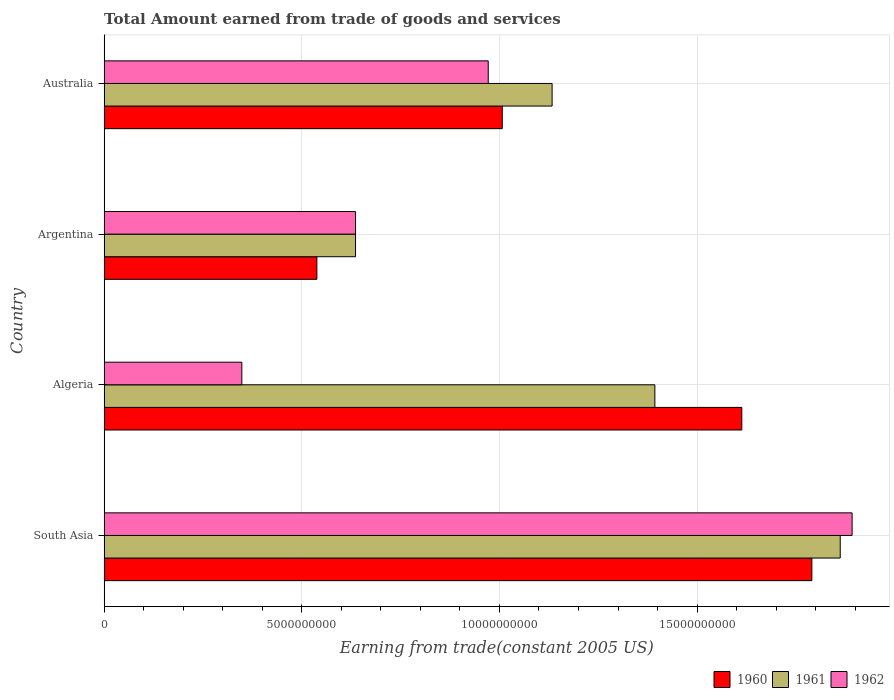Are the number of bars per tick equal to the number of legend labels?
Offer a terse response. Yes. Are the number of bars on each tick of the Y-axis equal?
Give a very brief answer. Yes. How many bars are there on the 3rd tick from the top?
Your answer should be very brief. 3. What is the label of the 3rd group of bars from the top?
Ensure brevity in your answer.  Algeria. In how many cases, is the number of bars for a given country not equal to the number of legend labels?
Ensure brevity in your answer.  0. What is the total amount earned by trading goods and services in 1960 in South Asia?
Offer a very short reply. 1.79e+1. Across all countries, what is the maximum total amount earned by trading goods and services in 1962?
Offer a very short reply. 1.89e+1. Across all countries, what is the minimum total amount earned by trading goods and services in 1962?
Keep it short and to the point. 3.48e+09. In which country was the total amount earned by trading goods and services in 1960 maximum?
Your answer should be compact. South Asia. What is the total total amount earned by trading goods and services in 1960 in the graph?
Offer a very short reply. 4.95e+1. What is the difference between the total amount earned by trading goods and services in 1962 in Algeria and that in South Asia?
Offer a terse response. -1.54e+1. What is the difference between the total amount earned by trading goods and services in 1960 in Algeria and the total amount earned by trading goods and services in 1961 in Australia?
Ensure brevity in your answer.  4.80e+09. What is the average total amount earned by trading goods and services in 1962 per country?
Your answer should be very brief. 9.62e+09. What is the difference between the total amount earned by trading goods and services in 1960 and total amount earned by trading goods and services in 1961 in Argentina?
Offer a terse response. -9.78e+08. What is the ratio of the total amount earned by trading goods and services in 1962 in Algeria to that in Argentina?
Offer a terse response. 0.55. Is the total amount earned by trading goods and services in 1962 in Australia less than that in South Asia?
Your response must be concise. Yes. What is the difference between the highest and the second highest total amount earned by trading goods and services in 1961?
Provide a short and direct response. 4.69e+09. What is the difference between the highest and the lowest total amount earned by trading goods and services in 1960?
Offer a terse response. 1.25e+1. What does the 2nd bar from the top in Algeria represents?
Give a very brief answer. 1961. Is it the case that in every country, the sum of the total amount earned by trading goods and services in 1961 and total amount earned by trading goods and services in 1960 is greater than the total amount earned by trading goods and services in 1962?
Keep it short and to the point. Yes. What is the difference between two consecutive major ticks on the X-axis?
Keep it short and to the point. 5.00e+09. Are the values on the major ticks of X-axis written in scientific E-notation?
Ensure brevity in your answer.  No. Does the graph contain grids?
Offer a very short reply. Yes. How are the legend labels stacked?
Offer a terse response. Horizontal. What is the title of the graph?
Ensure brevity in your answer.  Total Amount earned from trade of goods and services. What is the label or title of the X-axis?
Give a very brief answer. Earning from trade(constant 2005 US). What is the Earning from trade(constant 2005 US) of 1960 in South Asia?
Provide a short and direct response. 1.79e+1. What is the Earning from trade(constant 2005 US) in 1961 in South Asia?
Your answer should be compact. 1.86e+1. What is the Earning from trade(constant 2005 US) in 1962 in South Asia?
Keep it short and to the point. 1.89e+1. What is the Earning from trade(constant 2005 US) in 1960 in Algeria?
Your response must be concise. 1.61e+1. What is the Earning from trade(constant 2005 US) in 1961 in Algeria?
Offer a very short reply. 1.39e+1. What is the Earning from trade(constant 2005 US) in 1962 in Algeria?
Your response must be concise. 3.48e+09. What is the Earning from trade(constant 2005 US) in 1960 in Argentina?
Your response must be concise. 5.38e+09. What is the Earning from trade(constant 2005 US) of 1961 in Argentina?
Make the answer very short. 6.36e+09. What is the Earning from trade(constant 2005 US) in 1962 in Argentina?
Offer a very short reply. 6.36e+09. What is the Earning from trade(constant 2005 US) in 1960 in Australia?
Your response must be concise. 1.01e+1. What is the Earning from trade(constant 2005 US) of 1961 in Australia?
Provide a succinct answer. 1.13e+1. What is the Earning from trade(constant 2005 US) in 1962 in Australia?
Offer a terse response. 9.72e+09. Across all countries, what is the maximum Earning from trade(constant 2005 US) in 1960?
Your response must be concise. 1.79e+1. Across all countries, what is the maximum Earning from trade(constant 2005 US) of 1961?
Your answer should be compact. 1.86e+1. Across all countries, what is the maximum Earning from trade(constant 2005 US) of 1962?
Give a very brief answer. 1.89e+1. Across all countries, what is the minimum Earning from trade(constant 2005 US) in 1960?
Make the answer very short. 5.38e+09. Across all countries, what is the minimum Earning from trade(constant 2005 US) in 1961?
Ensure brevity in your answer.  6.36e+09. Across all countries, what is the minimum Earning from trade(constant 2005 US) of 1962?
Make the answer very short. 3.48e+09. What is the total Earning from trade(constant 2005 US) in 1960 in the graph?
Offer a terse response. 4.95e+1. What is the total Earning from trade(constant 2005 US) of 1961 in the graph?
Your answer should be very brief. 5.02e+1. What is the total Earning from trade(constant 2005 US) in 1962 in the graph?
Your response must be concise. 3.85e+1. What is the difference between the Earning from trade(constant 2005 US) of 1960 in South Asia and that in Algeria?
Your answer should be compact. 1.77e+09. What is the difference between the Earning from trade(constant 2005 US) of 1961 in South Asia and that in Algeria?
Ensure brevity in your answer.  4.69e+09. What is the difference between the Earning from trade(constant 2005 US) of 1962 in South Asia and that in Algeria?
Offer a very short reply. 1.54e+1. What is the difference between the Earning from trade(constant 2005 US) of 1960 in South Asia and that in Argentina?
Provide a succinct answer. 1.25e+1. What is the difference between the Earning from trade(constant 2005 US) of 1961 in South Asia and that in Argentina?
Provide a short and direct response. 1.23e+1. What is the difference between the Earning from trade(constant 2005 US) in 1962 in South Asia and that in Argentina?
Your answer should be compact. 1.26e+1. What is the difference between the Earning from trade(constant 2005 US) in 1960 in South Asia and that in Australia?
Offer a very short reply. 7.83e+09. What is the difference between the Earning from trade(constant 2005 US) in 1961 in South Asia and that in Australia?
Your answer should be very brief. 7.29e+09. What is the difference between the Earning from trade(constant 2005 US) of 1962 in South Asia and that in Australia?
Your answer should be very brief. 9.20e+09. What is the difference between the Earning from trade(constant 2005 US) in 1960 in Algeria and that in Argentina?
Offer a very short reply. 1.08e+1. What is the difference between the Earning from trade(constant 2005 US) in 1961 in Algeria and that in Argentina?
Offer a terse response. 7.57e+09. What is the difference between the Earning from trade(constant 2005 US) of 1962 in Algeria and that in Argentina?
Your answer should be compact. -2.88e+09. What is the difference between the Earning from trade(constant 2005 US) in 1960 in Algeria and that in Australia?
Your response must be concise. 6.06e+09. What is the difference between the Earning from trade(constant 2005 US) in 1961 in Algeria and that in Australia?
Make the answer very short. 2.60e+09. What is the difference between the Earning from trade(constant 2005 US) of 1962 in Algeria and that in Australia?
Your response must be concise. -6.23e+09. What is the difference between the Earning from trade(constant 2005 US) of 1960 in Argentina and that in Australia?
Provide a short and direct response. -4.69e+09. What is the difference between the Earning from trade(constant 2005 US) in 1961 in Argentina and that in Australia?
Provide a succinct answer. -4.97e+09. What is the difference between the Earning from trade(constant 2005 US) in 1962 in Argentina and that in Australia?
Keep it short and to the point. -3.36e+09. What is the difference between the Earning from trade(constant 2005 US) in 1960 in South Asia and the Earning from trade(constant 2005 US) in 1961 in Algeria?
Provide a short and direct response. 3.97e+09. What is the difference between the Earning from trade(constant 2005 US) of 1960 in South Asia and the Earning from trade(constant 2005 US) of 1962 in Algeria?
Your answer should be compact. 1.44e+1. What is the difference between the Earning from trade(constant 2005 US) of 1961 in South Asia and the Earning from trade(constant 2005 US) of 1962 in Algeria?
Offer a very short reply. 1.51e+1. What is the difference between the Earning from trade(constant 2005 US) of 1960 in South Asia and the Earning from trade(constant 2005 US) of 1961 in Argentina?
Provide a short and direct response. 1.15e+1. What is the difference between the Earning from trade(constant 2005 US) in 1960 in South Asia and the Earning from trade(constant 2005 US) in 1962 in Argentina?
Ensure brevity in your answer.  1.15e+1. What is the difference between the Earning from trade(constant 2005 US) in 1961 in South Asia and the Earning from trade(constant 2005 US) in 1962 in Argentina?
Offer a terse response. 1.23e+1. What is the difference between the Earning from trade(constant 2005 US) in 1960 in South Asia and the Earning from trade(constant 2005 US) in 1961 in Australia?
Your answer should be very brief. 6.57e+09. What is the difference between the Earning from trade(constant 2005 US) of 1960 in South Asia and the Earning from trade(constant 2005 US) of 1962 in Australia?
Ensure brevity in your answer.  8.19e+09. What is the difference between the Earning from trade(constant 2005 US) of 1961 in South Asia and the Earning from trade(constant 2005 US) of 1962 in Australia?
Your answer should be very brief. 8.90e+09. What is the difference between the Earning from trade(constant 2005 US) of 1960 in Algeria and the Earning from trade(constant 2005 US) of 1961 in Argentina?
Your answer should be very brief. 9.77e+09. What is the difference between the Earning from trade(constant 2005 US) in 1960 in Algeria and the Earning from trade(constant 2005 US) in 1962 in Argentina?
Offer a very short reply. 9.77e+09. What is the difference between the Earning from trade(constant 2005 US) in 1961 in Algeria and the Earning from trade(constant 2005 US) in 1962 in Argentina?
Offer a terse response. 7.57e+09. What is the difference between the Earning from trade(constant 2005 US) of 1960 in Algeria and the Earning from trade(constant 2005 US) of 1961 in Australia?
Your answer should be very brief. 4.80e+09. What is the difference between the Earning from trade(constant 2005 US) of 1960 in Algeria and the Earning from trade(constant 2005 US) of 1962 in Australia?
Give a very brief answer. 6.42e+09. What is the difference between the Earning from trade(constant 2005 US) in 1961 in Algeria and the Earning from trade(constant 2005 US) in 1962 in Australia?
Your answer should be very brief. 4.22e+09. What is the difference between the Earning from trade(constant 2005 US) in 1960 in Argentina and the Earning from trade(constant 2005 US) in 1961 in Australia?
Provide a succinct answer. -5.95e+09. What is the difference between the Earning from trade(constant 2005 US) of 1960 in Argentina and the Earning from trade(constant 2005 US) of 1962 in Australia?
Keep it short and to the point. -4.34e+09. What is the difference between the Earning from trade(constant 2005 US) of 1961 in Argentina and the Earning from trade(constant 2005 US) of 1962 in Australia?
Make the answer very short. -3.36e+09. What is the average Earning from trade(constant 2005 US) of 1960 per country?
Give a very brief answer. 1.24e+1. What is the average Earning from trade(constant 2005 US) in 1961 per country?
Your answer should be compact. 1.26e+1. What is the average Earning from trade(constant 2005 US) of 1962 per country?
Offer a very short reply. 9.62e+09. What is the difference between the Earning from trade(constant 2005 US) of 1960 and Earning from trade(constant 2005 US) of 1961 in South Asia?
Keep it short and to the point. -7.18e+08. What is the difference between the Earning from trade(constant 2005 US) of 1960 and Earning from trade(constant 2005 US) of 1962 in South Asia?
Make the answer very short. -1.02e+09. What is the difference between the Earning from trade(constant 2005 US) of 1961 and Earning from trade(constant 2005 US) of 1962 in South Asia?
Offer a terse response. -3.00e+08. What is the difference between the Earning from trade(constant 2005 US) of 1960 and Earning from trade(constant 2005 US) of 1961 in Algeria?
Make the answer very short. 2.20e+09. What is the difference between the Earning from trade(constant 2005 US) in 1960 and Earning from trade(constant 2005 US) in 1962 in Algeria?
Provide a succinct answer. 1.26e+1. What is the difference between the Earning from trade(constant 2005 US) of 1961 and Earning from trade(constant 2005 US) of 1962 in Algeria?
Make the answer very short. 1.04e+1. What is the difference between the Earning from trade(constant 2005 US) of 1960 and Earning from trade(constant 2005 US) of 1961 in Argentina?
Your response must be concise. -9.78e+08. What is the difference between the Earning from trade(constant 2005 US) of 1960 and Earning from trade(constant 2005 US) of 1962 in Argentina?
Make the answer very short. -9.78e+08. What is the difference between the Earning from trade(constant 2005 US) of 1960 and Earning from trade(constant 2005 US) of 1961 in Australia?
Keep it short and to the point. -1.26e+09. What is the difference between the Earning from trade(constant 2005 US) of 1960 and Earning from trade(constant 2005 US) of 1962 in Australia?
Offer a terse response. 3.55e+08. What is the difference between the Earning from trade(constant 2005 US) of 1961 and Earning from trade(constant 2005 US) of 1962 in Australia?
Give a very brief answer. 1.62e+09. What is the ratio of the Earning from trade(constant 2005 US) in 1960 in South Asia to that in Algeria?
Offer a very short reply. 1.11. What is the ratio of the Earning from trade(constant 2005 US) of 1961 in South Asia to that in Algeria?
Make the answer very short. 1.34. What is the ratio of the Earning from trade(constant 2005 US) in 1962 in South Asia to that in Algeria?
Keep it short and to the point. 5.43. What is the ratio of the Earning from trade(constant 2005 US) in 1960 in South Asia to that in Argentina?
Offer a very short reply. 3.33. What is the ratio of the Earning from trade(constant 2005 US) of 1961 in South Asia to that in Argentina?
Provide a succinct answer. 2.93. What is the ratio of the Earning from trade(constant 2005 US) in 1962 in South Asia to that in Argentina?
Your answer should be very brief. 2.98. What is the ratio of the Earning from trade(constant 2005 US) of 1960 in South Asia to that in Australia?
Make the answer very short. 1.78. What is the ratio of the Earning from trade(constant 2005 US) of 1961 in South Asia to that in Australia?
Offer a terse response. 1.64. What is the ratio of the Earning from trade(constant 2005 US) in 1962 in South Asia to that in Australia?
Make the answer very short. 1.95. What is the ratio of the Earning from trade(constant 2005 US) in 1960 in Algeria to that in Argentina?
Offer a terse response. 3. What is the ratio of the Earning from trade(constant 2005 US) in 1961 in Algeria to that in Argentina?
Provide a succinct answer. 2.19. What is the ratio of the Earning from trade(constant 2005 US) of 1962 in Algeria to that in Argentina?
Ensure brevity in your answer.  0.55. What is the ratio of the Earning from trade(constant 2005 US) of 1960 in Algeria to that in Australia?
Make the answer very short. 1.6. What is the ratio of the Earning from trade(constant 2005 US) of 1961 in Algeria to that in Australia?
Your answer should be compact. 1.23. What is the ratio of the Earning from trade(constant 2005 US) of 1962 in Algeria to that in Australia?
Provide a succinct answer. 0.36. What is the ratio of the Earning from trade(constant 2005 US) of 1960 in Argentina to that in Australia?
Give a very brief answer. 0.53. What is the ratio of the Earning from trade(constant 2005 US) of 1961 in Argentina to that in Australia?
Ensure brevity in your answer.  0.56. What is the ratio of the Earning from trade(constant 2005 US) of 1962 in Argentina to that in Australia?
Your answer should be compact. 0.65. What is the difference between the highest and the second highest Earning from trade(constant 2005 US) of 1960?
Ensure brevity in your answer.  1.77e+09. What is the difference between the highest and the second highest Earning from trade(constant 2005 US) in 1961?
Your answer should be very brief. 4.69e+09. What is the difference between the highest and the second highest Earning from trade(constant 2005 US) in 1962?
Provide a succinct answer. 9.20e+09. What is the difference between the highest and the lowest Earning from trade(constant 2005 US) of 1960?
Your answer should be compact. 1.25e+1. What is the difference between the highest and the lowest Earning from trade(constant 2005 US) of 1961?
Your answer should be very brief. 1.23e+1. What is the difference between the highest and the lowest Earning from trade(constant 2005 US) in 1962?
Offer a very short reply. 1.54e+1. 